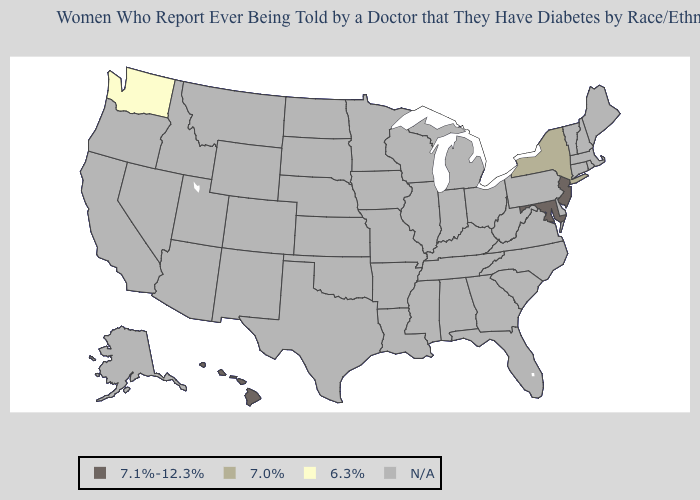Which states have the lowest value in the Northeast?
Concise answer only. New York. What is the lowest value in the USA?
Give a very brief answer. 6.3%. What is the value of Indiana?
Give a very brief answer. N/A. Name the states that have a value in the range N/A?
Be succinct. Alabama, Alaska, Arizona, Arkansas, California, Colorado, Connecticut, Delaware, Florida, Georgia, Idaho, Illinois, Indiana, Iowa, Kansas, Kentucky, Louisiana, Maine, Massachusetts, Michigan, Minnesota, Mississippi, Missouri, Montana, Nebraska, Nevada, New Hampshire, New Mexico, North Carolina, North Dakota, Ohio, Oklahoma, Oregon, Pennsylvania, Rhode Island, South Carolina, South Dakota, Tennessee, Texas, Utah, Vermont, Virginia, West Virginia, Wisconsin, Wyoming. Does the map have missing data?
Concise answer only. Yes. What is the lowest value in the USA?
Concise answer only. 6.3%. Name the states that have a value in the range N/A?
Quick response, please. Alabama, Alaska, Arizona, Arkansas, California, Colorado, Connecticut, Delaware, Florida, Georgia, Idaho, Illinois, Indiana, Iowa, Kansas, Kentucky, Louisiana, Maine, Massachusetts, Michigan, Minnesota, Mississippi, Missouri, Montana, Nebraska, Nevada, New Hampshire, New Mexico, North Carolina, North Dakota, Ohio, Oklahoma, Oregon, Pennsylvania, Rhode Island, South Carolina, South Dakota, Tennessee, Texas, Utah, Vermont, Virginia, West Virginia, Wisconsin, Wyoming. Is the legend a continuous bar?
Short answer required. No. What is the lowest value in the USA?
Give a very brief answer. 6.3%. What is the highest value in the USA?
Short answer required. 7.1%-12.3%. What is the value of Kansas?
Give a very brief answer. N/A. 